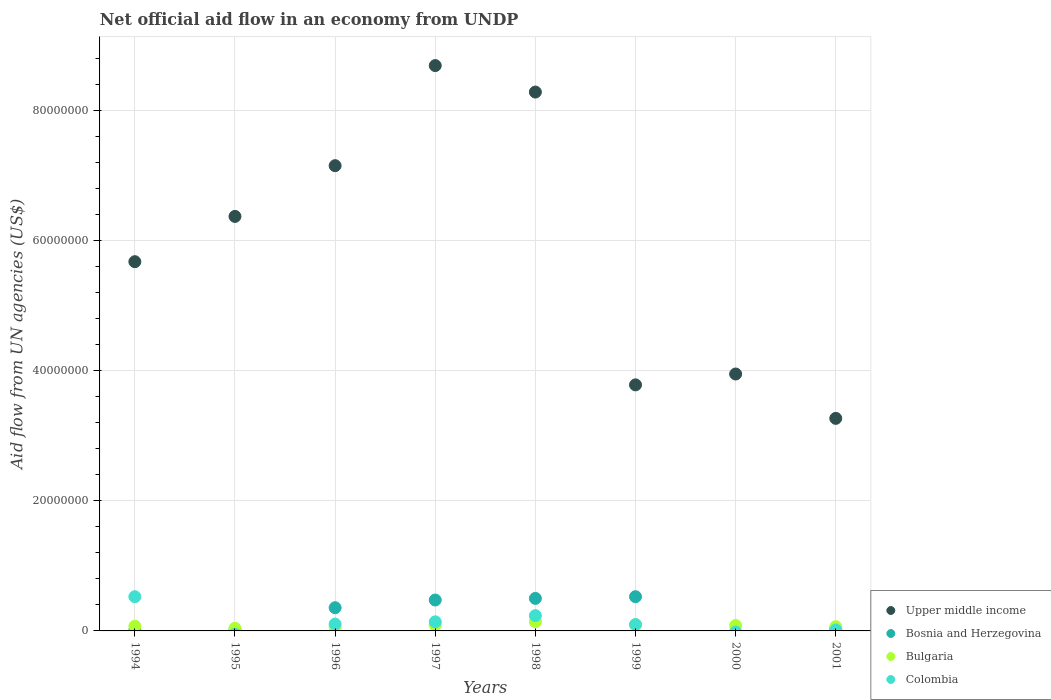How many different coloured dotlines are there?
Give a very brief answer. 4. Is the number of dotlines equal to the number of legend labels?
Your answer should be compact. No. What is the net official aid flow in Bosnia and Herzegovina in 1997?
Your answer should be compact. 4.75e+06. Across all years, what is the maximum net official aid flow in Colombia?
Provide a succinct answer. 5.26e+06. Across all years, what is the minimum net official aid flow in Bulgaria?
Your response must be concise. 4.00e+05. In which year was the net official aid flow in Upper middle income maximum?
Your answer should be very brief. 1997. What is the total net official aid flow in Upper middle income in the graph?
Offer a terse response. 4.72e+08. What is the difference between the net official aid flow in Colombia in 1997 and that in 2001?
Offer a terse response. 1.25e+06. What is the difference between the net official aid flow in Bosnia and Herzegovina in 1998 and the net official aid flow in Upper middle income in 1994?
Your answer should be very brief. -5.18e+07. What is the average net official aid flow in Bulgaria per year?
Ensure brevity in your answer.  8.10e+05. In the year 2001, what is the difference between the net official aid flow in Bosnia and Herzegovina and net official aid flow in Colombia?
Your response must be concise. 6.00e+04. What is the ratio of the net official aid flow in Bosnia and Herzegovina in 1997 to that in 1999?
Offer a terse response. 0.9. Is the net official aid flow in Upper middle income in 1994 less than that in 1997?
Provide a succinct answer. Yes. Is the difference between the net official aid flow in Bosnia and Herzegovina in 1994 and 1998 greater than the difference between the net official aid flow in Colombia in 1994 and 1998?
Your response must be concise. No. What is the difference between the highest and the second highest net official aid flow in Upper middle income?
Keep it short and to the point. 4.07e+06. What is the difference between the highest and the lowest net official aid flow in Upper middle income?
Your answer should be very brief. 5.42e+07. In how many years, is the net official aid flow in Bosnia and Herzegovina greater than the average net official aid flow in Bosnia and Herzegovina taken over all years?
Make the answer very short. 4. Is it the case that in every year, the sum of the net official aid flow in Upper middle income and net official aid flow in Bosnia and Herzegovina  is greater than the sum of net official aid flow in Colombia and net official aid flow in Bulgaria?
Give a very brief answer. Yes. Is it the case that in every year, the sum of the net official aid flow in Colombia and net official aid flow in Bosnia and Herzegovina  is greater than the net official aid flow in Bulgaria?
Your response must be concise. No. Is the net official aid flow in Colombia strictly greater than the net official aid flow in Upper middle income over the years?
Offer a terse response. No. How many years are there in the graph?
Provide a succinct answer. 8. What is the difference between two consecutive major ticks on the Y-axis?
Your answer should be compact. 2.00e+07. Are the values on the major ticks of Y-axis written in scientific E-notation?
Your response must be concise. No. Does the graph contain any zero values?
Give a very brief answer. Yes. Does the graph contain grids?
Your answer should be very brief. Yes. Where does the legend appear in the graph?
Your answer should be very brief. Bottom right. How many legend labels are there?
Your answer should be compact. 4. How are the legend labels stacked?
Your response must be concise. Vertical. What is the title of the graph?
Ensure brevity in your answer.  Net official aid flow in an economy from UNDP. What is the label or title of the X-axis?
Keep it short and to the point. Years. What is the label or title of the Y-axis?
Offer a very short reply. Aid flow from UN agencies (US$). What is the Aid flow from UN agencies (US$) in Upper middle income in 1994?
Offer a very short reply. 5.68e+07. What is the Aid flow from UN agencies (US$) of Bulgaria in 1994?
Your answer should be very brief. 7.20e+05. What is the Aid flow from UN agencies (US$) of Colombia in 1994?
Ensure brevity in your answer.  5.26e+06. What is the Aid flow from UN agencies (US$) of Upper middle income in 1995?
Your answer should be very brief. 6.37e+07. What is the Aid flow from UN agencies (US$) of Bosnia and Herzegovina in 1995?
Offer a terse response. 2.00e+05. What is the Aid flow from UN agencies (US$) in Upper middle income in 1996?
Your answer should be very brief. 7.15e+07. What is the Aid flow from UN agencies (US$) in Bosnia and Herzegovina in 1996?
Ensure brevity in your answer.  3.57e+06. What is the Aid flow from UN agencies (US$) in Colombia in 1996?
Your answer should be very brief. 1.05e+06. What is the Aid flow from UN agencies (US$) of Upper middle income in 1997?
Provide a short and direct response. 8.69e+07. What is the Aid flow from UN agencies (US$) of Bosnia and Herzegovina in 1997?
Offer a terse response. 4.75e+06. What is the Aid flow from UN agencies (US$) of Bulgaria in 1997?
Offer a terse response. 9.20e+05. What is the Aid flow from UN agencies (US$) in Colombia in 1997?
Make the answer very short. 1.40e+06. What is the Aid flow from UN agencies (US$) in Upper middle income in 1998?
Ensure brevity in your answer.  8.28e+07. What is the Aid flow from UN agencies (US$) of Bosnia and Herzegovina in 1998?
Provide a succinct answer. 5.00e+06. What is the Aid flow from UN agencies (US$) in Bulgaria in 1998?
Your answer should be very brief. 1.41e+06. What is the Aid flow from UN agencies (US$) of Colombia in 1998?
Provide a short and direct response. 2.35e+06. What is the Aid flow from UN agencies (US$) in Upper middle income in 1999?
Offer a terse response. 3.78e+07. What is the Aid flow from UN agencies (US$) of Bosnia and Herzegovina in 1999?
Give a very brief answer. 5.26e+06. What is the Aid flow from UN agencies (US$) of Bulgaria in 1999?
Offer a terse response. 9.50e+05. What is the Aid flow from UN agencies (US$) in Colombia in 1999?
Offer a terse response. 9.80e+05. What is the Aid flow from UN agencies (US$) in Upper middle income in 2000?
Offer a very short reply. 3.95e+07. What is the Aid flow from UN agencies (US$) of Bosnia and Herzegovina in 2000?
Your answer should be compact. 0. What is the Aid flow from UN agencies (US$) of Bulgaria in 2000?
Offer a terse response. 8.30e+05. What is the Aid flow from UN agencies (US$) in Upper middle income in 2001?
Provide a succinct answer. 3.27e+07. What is the Aid flow from UN agencies (US$) in Bulgaria in 2001?
Your response must be concise. 6.50e+05. Across all years, what is the maximum Aid flow from UN agencies (US$) in Upper middle income?
Offer a terse response. 8.69e+07. Across all years, what is the maximum Aid flow from UN agencies (US$) of Bosnia and Herzegovina?
Provide a succinct answer. 5.26e+06. Across all years, what is the maximum Aid flow from UN agencies (US$) in Bulgaria?
Your answer should be very brief. 1.41e+06. Across all years, what is the maximum Aid flow from UN agencies (US$) in Colombia?
Your response must be concise. 5.26e+06. Across all years, what is the minimum Aid flow from UN agencies (US$) of Upper middle income?
Make the answer very short. 3.27e+07. Across all years, what is the minimum Aid flow from UN agencies (US$) in Colombia?
Provide a succinct answer. 0. What is the total Aid flow from UN agencies (US$) of Upper middle income in the graph?
Make the answer very short. 4.72e+08. What is the total Aid flow from UN agencies (US$) in Bosnia and Herzegovina in the graph?
Give a very brief answer. 1.91e+07. What is the total Aid flow from UN agencies (US$) of Bulgaria in the graph?
Give a very brief answer. 6.48e+06. What is the total Aid flow from UN agencies (US$) in Colombia in the graph?
Your answer should be very brief. 1.12e+07. What is the difference between the Aid flow from UN agencies (US$) in Upper middle income in 1994 and that in 1995?
Your answer should be very brief. -6.96e+06. What is the difference between the Aid flow from UN agencies (US$) of Bulgaria in 1994 and that in 1995?
Your answer should be compact. 3.20e+05. What is the difference between the Aid flow from UN agencies (US$) of Upper middle income in 1994 and that in 1996?
Ensure brevity in your answer.  -1.48e+07. What is the difference between the Aid flow from UN agencies (US$) of Bosnia and Herzegovina in 1994 and that in 1996?
Ensure brevity in your answer.  -3.48e+06. What is the difference between the Aid flow from UN agencies (US$) of Colombia in 1994 and that in 1996?
Provide a succinct answer. 4.21e+06. What is the difference between the Aid flow from UN agencies (US$) of Upper middle income in 1994 and that in 1997?
Keep it short and to the point. -3.02e+07. What is the difference between the Aid flow from UN agencies (US$) of Bosnia and Herzegovina in 1994 and that in 1997?
Offer a very short reply. -4.66e+06. What is the difference between the Aid flow from UN agencies (US$) of Colombia in 1994 and that in 1997?
Your response must be concise. 3.86e+06. What is the difference between the Aid flow from UN agencies (US$) of Upper middle income in 1994 and that in 1998?
Provide a succinct answer. -2.61e+07. What is the difference between the Aid flow from UN agencies (US$) in Bosnia and Herzegovina in 1994 and that in 1998?
Ensure brevity in your answer.  -4.91e+06. What is the difference between the Aid flow from UN agencies (US$) in Bulgaria in 1994 and that in 1998?
Provide a succinct answer. -6.90e+05. What is the difference between the Aid flow from UN agencies (US$) of Colombia in 1994 and that in 1998?
Offer a very short reply. 2.91e+06. What is the difference between the Aid flow from UN agencies (US$) in Upper middle income in 1994 and that in 1999?
Your answer should be very brief. 1.89e+07. What is the difference between the Aid flow from UN agencies (US$) in Bosnia and Herzegovina in 1994 and that in 1999?
Provide a short and direct response. -5.17e+06. What is the difference between the Aid flow from UN agencies (US$) in Colombia in 1994 and that in 1999?
Provide a succinct answer. 4.28e+06. What is the difference between the Aid flow from UN agencies (US$) in Upper middle income in 1994 and that in 2000?
Give a very brief answer. 1.73e+07. What is the difference between the Aid flow from UN agencies (US$) in Bulgaria in 1994 and that in 2000?
Your answer should be compact. -1.10e+05. What is the difference between the Aid flow from UN agencies (US$) of Upper middle income in 1994 and that in 2001?
Give a very brief answer. 2.41e+07. What is the difference between the Aid flow from UN agencies (US$) of Bulgaria in 1994 and that in 2001?
Keep it short and to the point. 7.00e+04. What is the difference between the Aid flow from UN agencies (US$) in Colombia in 1994 and that in 2001?
Keep it short and to the point. 5.11e+06. What is the difference between the Aid flow from UN agencies (US$) in Upper middle income in 1995 and that in 1996?
Provide a short and direct response. -7.80e+06. What is the difference between the Aid flow from UN agencies (US$) of Bosnia and Herzegovina in 1995 and that in 1996?
Give a very brief answer. -3.37e+06. What is the difference between the Aid flow from UN agencies (US$) in Bulgaria in 1995 and that in 1996?
Provide a succinct answer. -2.00e+05. What is the difference between the Aid flow from UN agencies (US$) of Upper middle income in 1995 and that in 1997?
Offer a very short reply. -2.32e+07. What is the difference between the Aid flow from UN agencies (US$) in Bosnia and Herzegovina in 1995 and that in 1997?
Give a very brief answer. -4.55e+06. What is the difference between the Aid flow from UN agencies (US$) of Bulgaria in 1995 and that in 1997?
Provide a short and direct response. -5.20e+05. What is the difference between the Aid flow from UN agencies (US$) in Upper middle income in 1995 and that in 1998?
Offer a terse response. -1.91e+07. What is the difference between the Aid flow from UN agencies (US$) in Bosnia and Herzegovina in 1995 and that in 1998?
Provide a short and direct response. -4.80e+06. What is the difference between the Aid flow from UN agencies (US$) in Bulgaria in 1995 and that in 1998?
Your response must be concise. -1.01e+06. What is the difference between the Aid flow from UN agencies (US$) of Upper middle income in 1995 and that in 1999?
Provide a short and direct response. 2.59e+07. What is the difference between the Aid flow from UN agencies (US$) of Bosnia and Herzegovina in 1995 and that in 1999?
Provide a succinct answer. -5.06e+06. What is the difference between the Aid flow from UN agencies (US$) of Bulgaria in 1995 and that in 1999?
Offer a very short reply. -5.50e+05. What is the difference between the Aid flow from UN agencies (US$) in Upper middle income in 1995 and that in 2000?
Your answer should be compact. 2.42e+07. What is the difference between the Aid flow from UN agencies (US$) in Bulgaria in 1995 and that in 2000?
Offer a very short reply. -4.30e+05. What is the difference between the Aid flow from UN agencies (US$) in Upper middle income in 1995 and that in 2001?
Provide a succinct answer. 3.10e+07. What is the difference between the Aid flow from UN agencies (US$) in Bosnia and Herzegovina in 1995 and that in 2001?
Provide a short and direct response. -10000. What is the difference between the Aid flow from UN agencies (US$) in Bulgaria in 1995 and that in 2001?
Make the answer very short. -2.50e+05. What is the difference between the Aid flow from UN agencies (US$) of Upper middle income in 1996 and that in 1997?
Your response must be concise. -1.54e+07. What is the difference between the Aid flow from UN agencies (US$) in Bosnia and Herzegovina in 1996 and that in 1997?
Offer a terse response. -1.18e+06. What is the difference between the Aid flow from UN agencies (US$) in Bulgaria in 1996 and that in 1997?
Give a very brief answer. -3.20e+05. What is the difference between the Aid flow from UN agencies (US$) in Colombia in 1996 and that in 1997?
Ensure brevity in your answer.  -3.50e+05. What is the difference between the Aid flow from UN agencies (US$) in Upper middle income in 1996 and that in 1998?
Keep it short and to the point. -1.13e+07. What is the difference between the Aid flow from UN agencies (US$) in Bosnia and Herzegovina in 1996 and that in 1998?
Ensure brevity in your answer.  -1.43e+06. What is the difference between the Aid flow from UN agencies (US$) in Bulgaria in 1996 and that in 1998?
Provide a succinct answer. -8.10e+05. What is the difference between the Aid flow from UN agencies (US$) of Colombia in 1996 and that in 1998?
Your response must be concise. -1.30e+06. What is the difference between the Aid flow from UN agencies (US$) in Upper middle income in 1996 and that in 1999?
Keep it short and to the point. 3.37e+07. What is the difference between the Aid flow from UN agencies (US$) of Bosnia and Herzegovina in 1996 and that in 1999?
Your answer should be very brief. -1.69e+06. What is the difference between the Aid flow from UN agencies (US$) of Bulgaria in 1996 and that in 1999?
Your answer should be very brief. -3.50e+05. What is the difference between the Aid flow from UN agencies (US$) in Upper middle income in 1996 and that in 2000?
Provide a short and direct response. 3.20e+07. What is the difference between the Aid flow from UN agencies (US$) in Upper middle income in 1996 and that in 2001?
Keep it short and to the point. 3.88e+07. What is the difference between the Aid flow from UN agencies (US$) in Bosnia and Herzegovina in 1996 and that in 2001?
Offer a very short reply. 3.36e+06. What is the difference between the Aid flow from UN agencies (US$) in Colombia in 1996 and that in 2001?
Your response must be concise. 9.00e+05. What is the difference between the Aid flow from UN agencies (US$) of Upper middle income in 1997 and that in 1998?
Provide a succinct answer. 4.07e+06. What is the difference between the Aid flow from UN agencies (US$) in Bosnia and Herzegovina in 1997 and that in 1998?
Make the answer very short. -2.50e+05. What is the difference between the Aid flow from UN agencies (US$) in Bulgaria in 1997 and that in 1998?
Make the answer very short. -4.90e+05. What is the difference between the Aid flow from UN agencies (US$) of Colombia in 1997 and that in 1998?
Give a very brief answer. -9.50e+05. What is the difference between the Aid flow from UN agencies (US$) of Upper middle income in 1997 and that in 1999?
Your response must be concise. 4.91e+07. What is the difference between the Aid flow from UN agencies (US$) in Bosnia and Herzegovina in 1997 and that in 1999?
Ensure brevity in your answer.  -5.10e+05. What is the difference between the Aid flow from UN agencies (US$) in Bulgaria in 1997 and that in 1999?
Provide a succinct answer. -3.00e+04. What is the difference between the Aid flow from UN agencies (US$) in Colombia in 1997 and that in 1999?
Provide a short and direct response. 4.20e+05. What is the difference between the Aid flow from UN agencies (US$) of Upper middle income in 1997 and that in 2000?
Provide a succinct answer. 4.74e+07. What is the difference between the Aid flow from UN agencies (US$) of Upper middle income in 1997 and that in 2001?
Provide a short and direct response. 5.42e+07. What is the difference between the Aid flow from UN agencies (US$) in Bosnia and Herzegovina in 1997 and that in 2001?
Your answer should be compact. 4.54e+06. What is the difference between the Aid flow from UN agencies (US$) in Bulgaria in 1997 and that in 2001?
Provide a succinct answer. 2.70e+05. What is the difference between the Aid flow from UN agencies (US$) in Colombia in 1997 and that in 2001?
Offer a very short reply. 1.25e+06. What is the difference between the Aid flow from UN agencies (US$) in Upper middle income in 1998 and that in 1999?
Give a very brief answer. 4.50e+07. What is the difference between the Aid flow from UN agencies (US$) in Bulgaria in 1998 and that in 1999?
Give a very brief answer. 4.60e+05. What is the difference between the Aid flow from UN agencies (US$) of Colombia in 1998 and that in 1999?
Ensure brevity in your answer.  1.37e+06. What is the difference between the Aid flow from UN agencies (US$) in Upper middle income in 1998 and that in 2000?
Offer a terse response. 4.34e+07. What is the difference between the Aid flow from UN agencies (US$) of Bulgaria in 1998 and that in 2000?
Keep it short and to the point. 5.80e+05. What is the difference between the Aid flow from UN agencies (US$) in Upper middle income in 1998 and that in 2001?
Your answer should be very brief. 5.02e+07. What is the difference between the Aid flow from UN agencies (US$) in Bosnia and Herzegovina in 1998 and that in 2001?
Offer a very short reply. 4.79e+06. What is the difference between the Aid flow from UN agencies (US$) in Bulgaria in 1998 and that in 2001?
Provide a short and direct response. 7.60e+05. What is the difference between the Aid flow from UN agencies (US$) in Colombia in 1998 and that in 2001?
Provide a short and direct response. 2.20e+06. What is the difference between the Aid flow from UN agencies (US$) in Upper middle income in 1999 and that in 2000?
Provide a short and direct response. -1.67e+06. What is the difference between the Aid flow from UN agencies (US$) of Bulgaria in 1999 and that in 2000?
Give a very brief answer. 1.20e+05. What is the difference between the Aid flow from UN agencies (US$) of Upper middle income in 1999 and that in 2001?
Offer a very short reply. 5.15e+06. What is the difference between the Aid flow from UN agencies (US$) of Bosnia and Herzegovina in 1999 and that in 2001?
Ensure brevity in your answer.  5.05e+06. What is the difference between the Aid flow from UN agencies (US$) in Colombia in 1999 and that in 2001?
Your answer should be compact. 8.30e+05. What is the difference between the Aid flow from UN agencies (US$) of Upper middle income in 2000 and that in 2001?
Your response must be concise. 6.82e+06. What is the difference between the Aid flow from UN agencies (US$) of Bulgaria in 2000 and that in 2001?
Offer a terse response. 1.80e+05. What is the difference between the Aid flow from UN agencies (US$) in Upper middle income in 1994 and the Aid flow from UN agencies (US$) in Bosnia and Herzegovina in 1995?
Offer a very short reply. 5.66e+07. What is the difference between the Aid flow from UN agencies (US$) of Upper middle income in 1994 and the Aid flow from UN agencies (US$) of Bulgaria in 1995?
Offer a terse response. 5.64e+07. What is the difference between the Aid flow from UN agencies (US$) of Bosnia and Herzegovina in 1994 and the Aid flow from UN agencies (US$) of Bulgaria in 1995?
Provide a succinct answer. -3.10e+05. What is the difference between the Aid flow from UN agencies (US$) in Upper middle income in 1994 and the Aid flow from UN agencies (US$) in Bosnia and Herzegovina in 1996?
Give a very brief answer. 5.32e+07. What is the difference between the Aid flow from UN agencies (US$) of Upper middle income in 1994 and the Aid flow from UN agencies (US$) of Bulgaria in 1996?
Give a very brief answer. 5.62e+07. What is the difference between the Aid flow from UN agencies (US$) of Upper middle income in 1994 and the Aid flow from UN agencies (US$) of Colombia in 1996?
Give a very brief answer. 5.57e+07. What is the difference between the Aid flow from UN agencies (US$) of Bosnia and Herzegovina in 1994 and the Aid flow from UN agencies (US$) of Bulgaria in 1996?
Keep it short and to the point. -5.10e+05. What is the difference between the Aid flow from UN agencies (US$) of Bosnia and Herzegovina in 1994 and the Aid flow from UN agencies (US$) of Colombia in 1996?
Provide a succinct answer. -9.60e+05. What is the difference between the Aid flow from UN agencies (US$) in Bulgaria in 1994 and the Aid flow from UN agencies (US$) in Colombia in 1996?
Ensure brevity in your answer.  -3.30e+05. What is the difference between the Aid flow from UN agencies (US$) of Upper middle income in 1994 and the Aid flow from UN agencies (US$) of Bosnia and Herzegovina in 1997?
Make the answer very short. 5.20e+07. What is the difference between the Aid flow from UN agencies (US$) in Upper middle income in 1994 and the Aid flow from UN agencies (US$) in Bulgaria in 1997?
Your answer should be very brief. 5.58e+07. What is the difference between the Aid flow from UN agencies (US$) of Upper middle income in 1994 and the Aid flow from UN agencies (US$) of Colombia in 1997?
Your answer should be very brief. 5.54e+07. What is the difference between the Aid flow from UN agencies (US$) in Bosnia and Herzegovina in 1994 and the Aid flow from UN agencies (US$) in Bulgaria in 1997?
Keep it short and to the point. -8.30e+05. What is the difference between the Aid flow from UN agencies (US$) in Bosnia and Herzegovina in 1994 and the Aid flow from UN agencies (US$) in Colombia in 1997?
Keep it short and to the point. -1.31e+06. What is the difference between the Aid flow from UN agencies (US$) of Bulgaria in 1994 and the Aid flow from UN agencies (US$) of Colombia in 1997?
Your answer should be compact. -6.80e+05. What is the difference between the Aid flow from UN agencies (US$) of Upper middle income in 1994 and the Aid flow from UN agencies (US$) of Bosnia and Herzegovina in 1998?
Offer a terse response. 5.18e+07. What is the difference between the Aid flow from UN agencies (US$) of Upper middle income in 1994 and the Aid flow from UN agencies (US$) of Bulgaria in 1998?
Provide a succinct answer. 5.54e+07. What is the difference between the Aid flow from UN agencies (US$) in Upper middle income in 1994 and the Aid flow from UN agencies (US$) in Colombia in 1998?
Your answer should be very brief. 5.44e+07. What is the difference between the Aid flow from UN agencies (US$) in Bosnia and Herzegovina in 1994 and the Aid flow from UN agencies (US$) in Bulgaria in 1998?
Provide a succinct answer. -1.32e+06. What is the difference between the Aid flow from UN agencies (US$) of Bosnia and Herzegovina in 1994 and the Aid flow from UN agencies (US$) of Colombia in 1998?
Keep it short and to the point. -2.26e+06. What is the difference between the Aid flow from UN agencies (US$) in Bulgaria in 1994 and the Aid flow from UN agencies (US$) in Colombia in 1998?
Make the answer very short. -1.63e+06. What is the difference between the Aid flow from UN agencies (US$) in Upper middle income in 1994 and the Aid flow from UN agencies (US$) in Bosnia and Herzegovina in 1999?
Keep it short and to the point. 5.15e+07. What is the difference between the Aid flow from UN agencies (US$) of Upper middle income in 1994 and the Aid flow from UN agencies (US$) of Bulgaria in 1999?
Provide a short and direct response. 5.58e+07. What is the difference between the Aid flow from UN agencies (US$) in Upper middle income in 1994 and the Aid flow from UN agencies (US$) in Colombia in 1999?
Your response must be concise. 5.58e+07. What is the difference between the Aid flow from UN agencies (US$) of Bosnia and Herzegovina in 1994 and the Aid flow from UN agencies (US$) of Bulgaria in 1999?
Offer a terse response. -8.60e+05. What is the difference between the Aid flow from UN agencies (US$) of Bosnia and Herzegovina in 1994 and the Aid flow from UN agencies (US$) of Colombia in 1999?
Your answer should be very brief. -8.90e+05. What is the difference between the Aid flow from UN agencies (US$) of Upper middle income in 1994 and the Aid flow from UN agencies (US$) of Bulgaria in 2000?
Provide a short and direct response. 5.59e+07. What is the difference between the Aid flow from UN agencies (US$) in Bosnia and Herzegovina in 1994 and the Aid flow from UN agencies (US$) in Bulgaria in 2000?
Make the answer very short. -7.40e+05. What is the difference between the Aid flow from UN agencies (US$) in Upper middle income in 1994 and the Aid flow from UN agencies (US$) in Bosnia and Herzegovina in 2001?
Ensure brevity in your answer.  5.66e+07. What is the difference between the Aid flow from UN agencies (US$) of Upper middle income in 1994 and the Aid flow from UN agencies (US$) of Bulgaria in 2001?
Offer a terse response. 5.61e+07. What is the difference between the Aid flow from UN agencies (US$) in Upper middle income in 1994 and the Aid flow from UN agencies (US$) in Colombia in 2001?
Make the answer very short. 5.66e+07. What is the difference between the Aid flow from UN agencies (US$) of Bosnia and Herzegovina in 1994 and the Aid flow from UN agencies (US$) of Bulgaria in 2001?
Your answer should be compact. -5.60e+05. What is the difference between the Aid flow from UN agencies (US$) in Bosnia and Herzegovina in 1994 and the Aid flow from UN agencies (US$) in Colombia in 2001?
Provide a succinct answer. -6.00e+04. What is the difference between the Aid flow from UN agencies (US$) of Bulgaria in 1994 and the Aid flow from UN agencies (US$) of Colombia in 2001?
Keep it short and to the point. 5.70e+05. What is the difference between the Aid flow from UN agencies (US$) of Upper middle income in 1995 and the Aid flow from UN agencies (US$) of Bosnia and Herzegovina in 1996?
Your answer should be very brief. 6.02e+07. What is the difference between the Aid flow from UN agencies (US$) of Upper middle income in 1995 and the Aid flow from UN agencies (US$) of Bulgaria in 1996?
Keep it short and to the point. 6.31e+07. What is the difference between the Aid flow from UN agencies (US$) of Upper middle income in 1995 and the Aid flow from UN agencies (US$) of Colombia in 1996?
Offer a very short reply. 6.27e+07. What is the difference between the Aid flow from UN agencies (US$) of Bosnia and Herzegovina in 1995 and the Aid flow from UN agencies (US$) of Bulgaria in 1996?
Provide a succinct answer. -4.00e+05. What is the difference between the Aid flow from UN agencies (US$) of Bosnia and Herzegovina in 1995 and the Aid flow from UN agencies (US$) of Colombia in 1996?
Your response must be concise. -8.50e+05. What is the difference between the Aid flow from UN agencies (US$) in Bulgaria in 1995 and the Aid flow from UN agencies (US$) in Colombia in 1996?
Ensure brevity in your answer.  -6.50e+05. What is the difference between the Aid flow from UN agencies (US$) in Upper middle income in 1995 and the Aid flow from UN agencies (US$) in Bosnia and Herzegovina in 1997?
Your answer should be compact. 5.90e+07. What is the difference between the Aid flow from UN agencies (US$) of Upper middle income in 1995 and the Aid flow from UN agencies (US$) of Bulgaria in 1997?
Your answer should be compact. 6.28e+07. What is the difference between the Aid flow from UN agencies (US$) of Upper middle income in 1995 and the Aid flow from UN agencies (US$) of Colombia in 1997?
Offer a terse response. 6.23e+07. What is the difference between the Aid flow from UN agencies (US$) of Bosnia and Herzegovina in 1995 and the Aid flow from UN agencies (US$) of Bulgaria in 1997?
Your answer should be very brief. -7.20e+05. What is the difference between the Aid flow from UN agencies (US$) of Bosnia and Herzegovina in 1995 and the Aid flow from UN agencies (US$) of Colombia in 1997?
Your response must be concise. -1.20e+06. What is the difference between the Aid flow from UN agencies (US$) in Upper middle income in 1995 and the Aid flow from UN agencies (US$) in Bosnia and Herzegovina in 1998?
Your response must be concise. 5.87e+07. What is the difference between the Aid flow from UN agencies (US$) in Upper middle income in 1995 and the Aid flow from UN agencies (US$) in Bulgaria in 1998?
Offer a terse response. 6.23e+07. What is the difference between the Aid flow from UN agencies (US$) of Upper middle income in 1995 and the Aid flow from UN agencies (US$) of Colombia in 1998?
Your answer should be very brief. 6.14e+07. What is the difference between the Aid flow from UN agencies (US$) of Bosnia and Herzegovina in 1995 and the Aid flow from UN agencies (US$) of Bulgaria in 1998?
Ensure brevity in your answer.  -1.21e+06. What is the difference between the Aid flow from UN agencies (US$) of Bosnia and Herzegovina in 1995 and the Aid flow from UN agencies (US$) of Colombia in 1998?
Make the answer very short. -2.15e+06. What is the difference between the Aid flow from UN agencies (US$) in Bulgaria in 1995 and the Aid flow from UN agencies (US$) in Colombia in 1998?
Give a very brief answer. -1.95e+06. What is the difference between the Aid flow from UN agencies (US$) in Upper middle income in 1995 and the Aid flow from UN agencies (US$) in Bosnia and Herzegovina in 1999?
Your response must be concise. 5.85e+07. What is the difference between the Aid flow from UN agencies (US$) in Upper middle income in 1995 and the Aid flow from UN agencies (US$) in Bulgaria in 1999?
Your response must be concise. 6.28e+07. What is the difference between the Aid flow from UN agencies (US$) of Upper middle income in 1995 and the Aid flow from UN agencies (US$) of Colombia in 1999?
Offer a terse response. 6.28e+07. What is the difference between the Aid flow from UN agencies (US$) in Bosnia and Herzegovina in 1995 and the Aid flow from UN agencies (US$) in Bulgaria in 1999?
Your response must be concise. -7.50e+05. What is the difference between the Aid flow from UN agencies (US$) of Bosnia and Herzegovina in 1995 and the Aid flow from UN agencies (US$) of Colombia in 1999?
Offer a very short reply. -7.80e+05. What is the difference between the Aid flow from UN agencies (US$) in Bulgaria in 1995 and the Aid flow from UN agencies (US$) in Colombia in 1999?
Provide a short and direct response. -5.80e+05. What is the difference between the Aid flow from UN agencies (US$) of Upper middle income in 1995 and the Aid flow from UN agencies (US$) of Bulgaria in 2000?
Provide a succinct answer. 6.29e+07. What is the difference between the Aid flow from UN agencies (US$) in Bosnia and Herzegovina in 1995 and the Aid flow from UN agencies (US$) in Bulgaria in 2000?
Your answer should be very brief. -6.30e+05. What is the difference between the Aid flow from UN agencies (US$) of Upper middle income in 1995 and the Aid flow from UN agencies (US$) of Bosnia and Herzegovina in 2001?
Make the answer very short. 6.35e+07. What is the difference between the Aid flow from UN agencies (US$) in Upper middle income in 1995 and the Aid flow from UN agencies (US$) in Bulgaria in 2001?
Give a very brief answer. 6.31e+07. What is the difference between the Aid flow from UN agencies (US$) of Upper middle income in 1995 and the Aid flow from UN agencies (US$) of Colombia in 2001?
Keep it short and to the point. 6.36e+07. What is the difference between the Aid flow from UN agencies (US$) of Bosnia and Herzegovina in 1995 and the Aid flow from UN agencies (US$) of Bulgaria in 2001?
Keep it short and to the point. -4.50e+05. What is the difference between the Aid flow from UN agencies (US$) of Bosnia and Herzegovina in 1995 and the Aid flow from UN agencies (US$) of Colombia in 2001?
Your answer should be compact. 5.00e+04. What is the difference between the Aid flow from UN agencies (US$) of Bulgaria in 1995 and the Aid flow from UN agencies (US$) of Colombia in 2001?
Offer a terse response. 2.50e+05. What is the difference between the Aid flow from UN agencies (US$) in Upper middle income in 1996 and the Aid flow from UN agencies (US$) in Bosnia and Herzegovina in 1997?
Make the answer very short. 6.68e+07. What is the difference between the Aid flow from UN agencies (US$) in Upper middle income in 1996 and the Aid flow from UN agencies (US$) in Bulgaria in 1997?
Provide a succinct answer. 7.06e+07. What is the difference between the Aid flow from UN agencies (US$) of Upper middle income in 1996 and the Aid flow from UN agencies (US$) of Colombia in 1997?
Ensure brevity in your answer.  7.01e+07. What is the difference between the Aid flow from UN agencies (US$) in Bosnia and Herzegovina in 1996 and the Aid flow from UN agencies (US$) in Bulgaria in 1997?
Ensure brevity in your answer.  2.65e+06. What is the difference between the Aid flow from UN agencies (US$) of Bosnia and Herzegovina in 1996 and the Aid flow from UN agencies (US$) of Colombia in 1997?
Ensure brevity in your answer.  2.17e+06. What is the difference between the Aid flow from UN agencies (US$) of Bulgaria in 1996 and the Aid flow from UN agencies (US$) of Colombia in 1997?
Offer a terse response. -8.00e+05. What is the difference between the Aid flow from UN agencies (US$) of Upper middle income in 1996 and the Aid flow from UN agencies (US$) of Bosnia and Herzegovina in 1998?
Provide a short and direct response. 6.65e+07. What is the difference between the Aid flow from UN agencies (US$) of Upper middle income in 1996 and the Aid flow from UN agencies (US$) of Bulgaria in 1998?
Your answer should be compact. 7.01e+07. What is the difference between the Aid flow from UN agencies (US$) of Upper middle income in 1996 and the Aid flow from UN agencies (US$) of Colombia in 1998?
Ensure brevity in your answer.  6.92e+07. What is the difference between the Aid flow from UN agencies (US$) of Bosnia and Herzegovina in 1996 and the Aid flow from UN agencies (US$) of Bulgaria in 1998?
Give a very brief answer. 2.16e+06. What is the difference between the Aid flow from UN agencies (US$) of Bosnia and Herzegovina in 1996 and the Aid flow from UN agencies (US$) of Colombia in 1998?
Give a very brief answer. 1.22e+06. What is the difference between the Aid flow from UN agencies (US$) of Bulgaria in 1996 and the Aid flow from UN agencies (US$) of Colombia in 1998?
Make the answer very short. -1.75e+06. What is the difference between the Aid flow from UN agencies (US$) of Upper middle income in 1996 and the Aid flow from UN agencies (US$) of Bosnia and Herzegovina in 1999?
Provide a short and direct response. 6.63e+07. What is the difference between the Aid flow from UN agencies (US$) in Upper middle income in 1996 and the Aid flow from UN agencies (US$) in Bulgaria in 1999?
Ensure brevity in your answer.  7.06e+07. What is the difference between the Aid flow from UN agencies (US$) of Upper middle income in 1996 and the Aid flow from UN agencies (US$) of Colombia in 1999?
Your answer should be compact. 7.06e+07. What is the difference between the Aid flow from UN agencies (US$) in Bosnia and Herzegovina in 1996 and the Aid flow from UN agencies (US$) in Bulgaria in 1999?
Your response must be concise. 2.62e+06. What is the difference between the Aid flow from UN agencies (US$) in Bosnia and Herzegovina in 1996 and the Aid flow from UN agencies (US$) in Colombia in 1999?
Make the answer very short. 2.59e+06. What is the difference between the Aid flow from UN agencies (US$) in Bulgaria in 1996 and the Aid flow from UN agencies (US$) in Colombia in 1999?
Your answer should be compact. -3.80e+05. What is the difference between the Aid flow from UN agencies (US$) in Upper middle income in 1996 and the Aid flow from UN agencies (US$) in Bulgaria in 2000?
Your answer should be very brief. 7.07e+07. What is the difference between the Aid flow from UN agencies (US$) in Bosnia and Herzegovina in 1996 and the Aid flow from UN agencies (US$) in Bulgaria in 2000?
Your response must be concise. 2.74e+06. What is the difference between the Aid flow from UN agencies (US$) of Upper middle income in 1996 and the Aid flow from UN agencies (US$) of Bosnia and Herzegovina in 2001?
Ensure brevity in your answer.  7.13e+07. What is the difference between the Aid flow from UN agencies (US$) of Upper middle income in 1996 and the Aid flow from UN agencies (US$) of Bulgaria in 2001?
Offer a terse response. 7.09e+07. What is the difference between the Aid flow from UN agencies (US$) of Upper middle income in 1996 and the Aid flow from UN agencies (US$) of Colombia in 2001?
Provide a succinct answer. 7.14e+07. What is the difference between the Aid flow from UN agencies (US$) in Bosnia and Herzegovina in 1996 and the Aid flow from UN agencies (US$) in Bulgaria in 2001?
Offer a very short reply. 2.92e+06. What is the difference between the Aid flow from UN agencies (US$) of Bosnia and Herzegovina in 1996 and the Aid flow from UN agencies (US$) of Colombia in 2001?
Your answer should be compact. 3.42e+06. What is the difference between the Aid flow from UN agencies (US$) in Upper middle income in 1997 and the Aid flow from UN agencies (US$) in Bosnia and Herzegovina in 1998?
Give a very brief answer. 8.19e+07. What is the difference between the Aid flow from UN agencies (US$) in Upper middle income in 1997 and the Aid flow from UN agencies (US$) in Bulgaria in 1998?
Ensure brevity in your answer.  8.55e+07. What is the difference between the Aid flow from UN agencies (US$) of Upper middle income in 1997 and the Aid flow from UN agencies (US$) of Colombia in 1998?
Keep it short and to the point. 8.46e+07. What is the difference between the Aid flow from UN agencies (US$) of Bosnia and Herzegovina in 1997 and the Aid flow from UN agencies (US$) of Bulgaria in 1998?
Your answer should be compact. 3.34e+06. What is the difference between the Aid flow from UN agencies (US$) of Bosnia and Herzegovina in 1997 and the Aid flow from UN agencies (US$) of Colombia in 1998?
Your answer should be very brief. 2.40e+06. What is the difference between the Aid flow from UN agencies (US$) of Bulgaria in 1997 and the Aid flow from UN agencies (US$) of Colombia in 1998?
Give a very brief answer. -1.43e+06. What is the difference between the Aid flow from UN agencies (US$) of Upper middle income in 1997 and the Aid flow from UN agencies (US$) of Bosnia and Herzegovina in 1999?
Provide a short and direct response. 8.17e+07. What is the difference between the Aid flow from UN agencies (US$) in Upper middle income in 1997 and the Aid flow from UN agencies (US$) in Bulgaria in 1999?
Your answer should be very brief. 8.60e+07. What is the difference between the Aid flow from UN agencies (US$) in Upper middle income in 1997 and the Aid flow from UN agencies (US$) in Colombia in 1999?
Offer a terse response. 8.59e+07. What is the difference between the Aid flow from UN agencies (US$) of Bosnia and Herzegovina in 1997 and the Aid flow from UN agencies (US$) of Bulgaria in 1999?
Provide a succinct answer. 3.80e+06. What is the difference between the Aid flow from UN agencies (US$) of Bosnia and Herzegovina in 1997 and the Aid flow from UN agencies (US$) of Colombia in 1999?
Provide a succinct answer. 3.77e+06. What is the difference between the Aid flow from UN agencies (US$) of Upper middle income in 1997 and the Aid flow from UN agencies (US$) of Bulgaria in 2000?
Offer a very short reply. 8.61e+07. What is the difference between the Aid flow from UN agencies (US$) in Bosnia and Herzegovina in 1997 and the Aid flow from UN agencies (US$) in Bulgaria in 2000?
Offer a very short reply. 3.92e+06. What is the difference between the Aid flow from UN agencies (US$) in Upper middle income in 1997 and the Aid flow from UN agencies (US$) in Bosnia and Herzegovina in 2001?
Give a very brief answer. 8.67e+07. What is the difference between the Aid flow from UN agencies (US$) in Upper middle income in 1997 and the Aid flow from UN agencies (US$) in Bulgaria in 2001?
Ensure brevity in your answer.  8.63e+07. What is the difference between the Aid flow from UN agencies (US$) in Upper middle income in 1997 and the Aid flow from UN agencies (US$) in Colombia in 2001?
Give a very brief answer. 8.68e+07. What is the difference between the Aid flow from UN agencies (US$) of Bosnia and Herzegovina in 1997 and the Aid flow from UN agencies (US$) of Bulgaria in 2001?
Offer a terse response. 4.10e+06. What is the difference between the Aid flow from UN agencies (US$) in Bosnia and Herzegovina in 1997 and the Aid flow from UN agencies (US$) in Colombia in 2001?
Make the answer very short. 4.60e+06. What is the difference between the Aid flow from UN agencies (US$) of Bulgaria in 1997 and the Aid flow from UN agencies (US$) of Colombia in 2001?
Your answer should be very brief. 7.70e+05. What is the difference between the Aid flow from UN agencies (US$) of Upper middle income in 1998 and the Aid flow from UN agencies (US$) of Bosnia and Herzegovina in 1999?
Your response must be concise. 7.76e+07. What is the difference between the Aid flow from UN agencies (US$) in Upper middle income in 1998 and the Aid flow from UN agencies (US$) in Bulgaria in 1999?
Ensure brevity in your answer.  8.19e+07. What is the difference between the Aid flow from UN agencies (US$) in Upper middle income in 1998 and the Aid flow from UN agencies (US$) in Colombia in 1999?
Provide a short and direct response. 8.19e+07. What is the difference between the Aid flow from UN agencies (US$) in Bosnia and Herzegovina in 1998 and the Aid flow from UN agencies (US$) in Bulgaria in 1999?
Give a very brief answer. 4.05e+06. What is the difference between the Aid flow from UN agencies (US$) of Bosnia and Herzegovina in 1998 and the Aid flow from UN agencies (US$) of Colombia in 1999?
Keep it short and to the point. 4.02e+06. What is the difference between the Aid flow from UN agencies (US$) of Upper middle income in 1998 and the Aid flow from UN agencies (US$) of Bulgaria in 2000?
Offer a terse response. 8.20e+07. What is the difference between the Aid flow from UN agencies (US$) of Bosnia and Herzegovina in 1998 and the Aid flow from UN agencies (US$) of Bulgaria in 2000?
Keep it short and to the point. 4.17e+06. What is the difference between the Aid flow from UN agencies (US$) in Upper middle income in 1998 and the Aid flow from UN agencies (US$) in Bosnia and Herzegovina in 2001?
Offer a very short reply. 8.26e+07. What is the difference between the Aid flow from UN agencies (US$) of Upper middle income in 1998 and the Aid flow from UN agencies (US$) of Bulgaria in 2001?
Provide a short and direct response. 8.22e+07. What is the difference between the Aid flow from UN agencies (US$) in Upper middle income in 1998 and the Aid flow from UN agencies (US$) in Colombia in 2001?
Provide a succinct answer. 8.27e+07. What is the difference between the Aid flow from UN agencies (US$) in Bosnia and Herzegovina in 1998 and the Aid flow from UN agencies (US$) in Bulgaria in 2001?
Your response must be concise. 4.35e+06. What is the difference between the Aid flow from UN agencies (US$) of Bosnia and Herzegovina in 1998 and the Aid flow from UN agencies (US$) of Colombia in 2001?
Ensure brevity in your answer.  4.85e+06. What is the difference between the Aid flow from UN agencies (US$) of Bulgaria in 1998 and the Aid flow from UN agencies (US$) of Colombia in 2001?
Your answer should be very brief. 1.26e+06. What is the difference between the Aid flow from UN agencies (US$) of Upper middle income in 1999 and the Aid flow from UN agencies (US$) of Bulgaria in 2000?
Keep it short and to the point. 3.70e+07. What is the difference between the Aid flow from UN agencies (US$) in Bosnia and Herzegovina in 1999 and the Aid flow from UN agencies (US$) in Bulgaria in 2000?
Ensure brevity in your answer.  4.43e+06. What is the difference between the Aid flow from UN agencies (US$) of Upper middle income in 1999 and the Aid flow from UN agencies (US$) of Bosnia and Herzegovina in 2001?
Give a very brief answer. 3.76e+07. What is the difference between the Aid flow from UN agencies (US$) in Upper middle income in 1999 and the Aid flow from UN agencies (US$) in Bulgaria in 2001?
Offer a very short reply. 3.72e+07. What is the difference between the Aid flow from UN agencies (US$) of Upper middle income in 1999 and the Aid flow from UN agencies (US$) of Colombia in 2001?
Offer a terse response. 3.77e+07. What is the difference between the Aid flow from UN agencies (US$) in Bosnia and Herzegovina in 1999 and the Aid flow from UN agencies (US$) in Bulgaria in 2001?
Make the answer very short. 4.61e+06. What is the difference between the Aid flow from UN agencies (US$) of Bosnia and Herzegovina in 1999 and the Aid flow from UN agencies (US$) of Colombia in 2001?
Keep it short and to the point. 5.11e+06. What is the difference between the Aid flow from UN agencies (US$) of Upper middle income in 2000 and the Aid flow from UN agencies (US$) of Bosnia and Herzegovina in 2001?
Your answer should be compact. 3.93e+07. What is the difference between the Aid flow from UN agencies (US$) in Upper middle income in 2000 and the Aid flow from UN agencies (US$) in Bulgaria in 2001?
Your answer should be compact. 3.88e+07. What is the difference between the Aid flow from UN agencies (US$) of Upper middle income in 2000 and the Aid flow from UN agencies (US$) of Colombia in 2001?
Your answer should be compact. 3.94e+07. What is the difference between the Aid flow from UN agencies (US$) of Bulgaria in 2000 and the Aid flow from UN agencies (US$) of Colombia in 2001?
Provide a short and direct response. 6.80e+05. What is the average Aid flow from UN agencies (US$) of Upper middle income per year?
Provide a short and direct response. 5.90e+07. What is the average Aid flow from UN agencies (US$) in Bosnia and Herzegovina per year?
Your response must be concise. 2.38e+06. What is the average Aid flow from UN agencies (US$) of Bulgaria per year?
Offer a terse response. 8.10e+05. What is the average Aid flow from UN agencies (US$) in Colombia per year?
Provide a short and direct response. 1.40e+06. In the year 1994, what is the difference between the Aid flow from UN agencies (US$) in Upper middle income and Aid flow from UN agencies (US$) in Bosnia and Herzegovina?
Offer a terse response. 5.67e+07. In the year 1994, what is the difference between the Aid flow from UN agencies (US$) of Upper middle income and Aid flow from UN agencies (US$) of Bulgaria?
Make the answer very short. 5.60e+07. In the year 1994, what is the difference between the Aid flow from UN agencies (US$) of Upper middle income and Aid flow from UN agencies (US$) of Colombia?
Offer a very short reply. 5.15e+07. In the year 1994, what is the difference between the Aid flow from UN agencies (US$) in Bosnia and Herzegovina and Aid flow from UN agencies (US$) in Bulgaria?
Offer a terse response. -6.30e+05. In the year 1994, what is the difference between the Aid flow from UN agencies (US$) in Bosnia and Herzegovina and Aid flow from UN agencies (US$) in Colombia?
Offer a very short reply. -5.17e+06. In the year 1994, what is the difference between the Aid flow from UN agencies (US$) in Bulgaria and Aid flow from UN agencies (US$) in Colombia?
Give a very brief answer. -4.54e+06. In the year 1995, what is the difference between the Aid flow from UN agencies (US$) of Upper middle income and Aid flow from UN agencies (US$) of Bosnia and Herzegovina?
Ensure brevity in your answer.  6.35e+07. In the year 1995, what is the difference between the Aid flow from UN agencies (US$) in Upper middle income and Aid flow from UN agencies (US$) in Bulgaria?
Your answer should be very brief. 6.33e+07. In the year 1996, what is the difference between the Aid flow from UN agencies (US$) of Upper middle income and Aid flow from UN agencies (US$) of Bosnia and Herzegovina?
Provide a succinct answer. 6.80e+07. In the year 1996, what is the difference between the Aid flow from UN agencies (US$) in Upper middle income and Aid flow from UN agencies (US$) in Bulgaria?
Provide a succinct answer. 7.09e+07. In the year 1996, what is the difference between the Aid flow from UN agencies (US$) in Upper middle income and Aid flow from UN agencies (US$) in Colombia?
Your answer should be very brief. 7.05e+07. In the year 1996, what is the difference between the Aid flow from UN agencies (US$) of Bosnia and Herzegovina and Aid flow from UN agencies (US$) of Bulgaria?
Make the answer very short. 2.97e+06. In the year 1996, what is the difference between the Aid flow from UN agencies (US$) of Bosnia and Herzegovina and Aid flow from UN agencies (US$) of Colombia?
Keep it short and to the point. 2.52e+06. In the year 1996, what is the difference between the Aid flow from UN agencies (US$) in Bulgaria and Aid flow from UN agencies (US$) in Colombia?
Your response must be concise. -4.50e+05. In the year 1997, what is the difference between the Aid flow from UN agencies (US$) of Upper middle income and Aid flow from UN agencies (US$) of Bosnia and Herzegovina?
Provide a short and direct response. 8.22e+07. In the year 1997, what is the difference between the Aid flow from UN agencies (US$) of Upper middle income and Aid flow from UN agencies (US$) of Bulgaria?
Provide a succinct answer. 8.60e+07. In the year 1997, what is the difference between the Aid flow from UN agencies (US$) of Upper middle income and Aid flow from UN agencies (US$) of Colombia?
Provide a short and direct response. 8.55e+07. In the year 1997, what is the difference between the Aid flow from UN agencies (US$) in Bosnia and Herzegovina and Aid flow from UN agencies (US$) in Bulgaria?
Your answer should be compact. 3.83e+06. In the year 1997, what is the difference between the Aid flow from UN agencies (US$) of Bosnia and Herzegovina and Aid flow from UN agencies (US$) of Colombia?
Make the answer very short. 3.35e+06. In the year 1997, what is the difference between the Aid flow from UN agencies (US$) in Bulgaria and Aid flow from UN agencies (US$) in Colombia?
Keep it short and to the point. -4.80e+05. In the year 1998, what is the difference between the Aid flow from UN agencies (US$) in Upper middle income and Aid flow from UN agencies (US$) in Bosnia and Herzegovina?
Offer a terse response. 7.78e+07. In the year 1998, what is the difference between the Aid flow from UN agencies (US$) of Upper middle income and Aid flow from UN agencies (US$) of Bulgaria?
Give a very brief answer. 8.14e+07. In the year 1998, what is the difference between the Aid flow from UN agencies (US$) of Upper middle income and Aid flow from UN agencies (US$) of Colombia?
Offer a terse response. 8.05e+07. In the year 1998, what is the difference between the Aid flow from UN agencies (US$) in Bosnia and Herzegovina and Aid flow from UN agencies (US$) in Bulgaria?
Offer a terse response. 3.59e+06. In the year 1998, what is the difference between the Aid flow from UN agencies (US$) of Bosnia and Herzegovina and Aid flow from UN agencies (US$) of Colombia?
Your response must be concise. 2.65e+06. In the year 1998, what is the difference between the Aid flow from UN agencies (US$) of Bulgaria and Aid flow from UN agencies (US$) of Colombia?
Your answer should be compact. -9.40e+05. In the year 1999, what is the difference between the Aid flow from UN agencies (US$) in Upper middle income and Aid flow from UN agencies (US$) in Bosnia and Herzegovina?
Ensure brevity in your answer.  3.26e+07. In the year 1999, what is the difference between the Aid flow from UN agencies (US$) in Upper middle income and Aid flow from UN agencies (US$) in Bulgaria?
Offer a terse response. 3.69e+07. In the year 1999, what is the difference between the Aid flow from UN agencies (US$) of Upper middle income and Aid flow from UN agencies (US$) of Colombia?
Provide a short and direct response. 3.68e+07. In the year 1999, what is the difference between the Aid flow from UN agencies (US$) in Bosnia and Herzegovina and Aid flow from UN agencies (US$) in Bulgaria?
Provide a short and direct response. 4.31e+06. In the year 1999, what is the difference between the Aid flow from UN agencies (US$) of Bosnia and Herzegovina and Aid flow from UN agencies (US$) of Colombia?
Keep it short and to the point. 4.28e+06. In the year 1999, what is the difference between the Aid flow from UN agencies (US$) of Bulgaria and Aid flow from UN agencies (US$) of Colombia?
Your response must be concise. -3.00e+04. In the year 2000, what is the difference between the Aid flow from UN agencies (US$) of Upper middle income and Aid flow from UN agencies (US$) of Bulgaria?
Your answer should be compact. 3.87e+07. In the year 2001, what is the difference between the Aid flow from UN agencies (US$) in Upper middle income and Aid flow from UN agencies (US$) in Bosnia and Herzegovina?
Keep it short and to the point. 3.25e+07. In the year 2001, what is the difference between the Aid flow from UN agencies (US$) in Upper middle income and Aid flow from UN agencies (US$) in Bulgaria?
Offer a very short reply. 3.20e+07. In the year 2001, what is the difference between the Aid flow from UN agencies (US$) of Upper middle income and Aid flow from UN agencies (US$) of Colombia?
Your answer should be very brief. 3.25e+07. In the year 2001, what is the difference between the Aid flow from UN agencies (US$) in Bosnia and Herzegovina and Aid flow from UN agencies (US$) in Bulgaria?
Your answer should be very brief. -4.40e+05. In the year 2001, what is the difference between the Aid flow from UN agencies (US$) of Bosnia and Herzegovina and Aid flow from UN agencies (US$) of Colombia?
Ensure brevity in your answer.  6.00e+04. What is the ratio of the Aid flow from UN agencies (US$) of Upper middle income in 1994 to that in 1995?
Provide a succinct answer. 0.89. What is the ratio of the Aid flow from UN agencies (US$) of Bosnia and Herzegovina in 1994 to that in 1995?
Your answer should be very brief. 0.45. What is the ratio of the Aid flow from UN agencies (US$) in Bulgaria in 1994 to that in 1995?
Provide a short and direct response. 1.8. What is the ratio of the Aid flow from UN agencies (US$) in Upper middle income in 1994 to that in 1996?
Keep it short and to the point. 0.79. What is the ratio of the Aid flow from UN agencies (US$) of Bosnia and Herzegovina in 1994 to that in 1996?
Offer a terse response. 0.03. What is the ratio of the Aid flow from UN agencies (US$) in Colombia in 1994 to that in 1996?
Make the answer very short. 5.01. What is the ratio of the Aid flow from UN agencies (US$) of Upper middle income in 1994 to that in 1997?
Keep it short and to the point. 0.65. What is the ratio of the Aid flow from UN agencies (US$) in Bosnia and Herzegovina in 1994 to that in 1997?
Give a very brief answer. 0.02. What is the ratio of the Aid flow from UN agencies (US$) of Bulgaria in 1994 to that in 1997?
Provide a succinct answer. 0.78. What is the ratio of the Aid flow from UN agencies (US$) of Colombia in 1994 to that in 1997?
Your answer should be compact. 3.76. What is the ratio of the Aid flow from UN agencies (US$) of Upper middle income in 1994 to that in 1998?
Your answer should be very brief. 0.69. What is the ratio of the Aid flow from UN agencies (US$) of Bosnia and Herzegovina in 1994 to that in 1998?
Offer a very short reply. 0.02. What is the ratio of the Aid flow from UN agencies (US$) in Bulgaria in 1994 to that in 1998?
Offer a very short reply. 0.51. What is the ratio of the Aid flow from UN agencies (US$) of Colombia in 1994 to that in 1998?
Provide a succinct answer. 2.24. What is the ratio of the Aid flow from UN agencies (US$) of Upper middle income in 1994 to that in 1999?
Offer a terse response. 1.5. What is the ratio of the Aid flow from UN agencies (US$) in Bosnia and Herzegovina in 1994 to that in 1999?
Keep it short and to the point. 0.02. What is the ratio of the Aid flow from UN agencies (US$) of Bulgaria in 1994 to that in 1999?
Make the answer very short. 0.76. What is the ratio of the Aid flow from UN agencies (US$) in Colombia in 1994 to that in 1999?
Provide a succinct answer. 5.37. What is the ratio of the Aid flow from UN agencies (US$) of Upper middle income in 1994 to that in 2000?
Offer a terse response. 1.44. What is the ratio of the Aid flow from UN agencies (US$) of Bulgaria in 1994 to that in 2000?
Offer a very short reply. 0.87. What is the ratio of the Aid flow from UN agencies (US$) in Upper middle income in 1994 to that in 2001?
Your answer should be compact. 1.74. What is the ratio of the Aid flow from UN agencies (US$) in Bosnia and Herzegovina in 1994 to that in 2001?
Give a very brief answer. 0.43. What is the ratio of the Aid flow from UN agencies (US$) of Bulgaria in 1994 to that in 2001?
Offer a very short reply. 1.11. What is the ratio of the Aid flow from UN agencies (US$) of Colombia in 1994 to that in 2001?
Your answer should be compact. 35.07. What is the ratio of the Aid flow from UN agencies (US$) of Upper middle income in 1995 to that in 1996?
Offer a terse response. 0.89. What is the ratio of the Aid flow from UN agencies (US$) in Bosnia and Herzegovina in 1995 to that in 1996?
Offer a very short reply. 0.06. What is the ratio of the Aid flow from UN agencies (US$) of Bulgaria in 1995 to that in 1996?
Give a very brief answer. 0.67. What is the ratio of the Aid flow from UN agencies (US$) of Upper middle income in 1995 to that in 1997?
Keep it short and to the point. 0.73. What is the ratio of the Aid flow from UN agencies (US$) of Bosnia and Herzegovina in 1995 to that in 1997?
Give a very brief answer. 0.04. What is the ratio of the Aid flow from UN agencies (US$) of Bulgaria in 1995 to that in 1997?
Offer a very short reply. 0.43. What is the ratio of the Aid flow from UN agencies (US$) in Upper middle income in 1995 to that in 1998?
Keep it short and to the point. 0.77. What is the ratio of the Aid flow from UN agencies (US$) in Bulgaria in 1995 to that in 1998?
Your response must be concise. 0.28. What is the ratio of the Aid flow from UN agencies (US$) in Upper middle income in 1995 to that in 1999?
Keep it short and to the point. 1.68. What is the ratio of the Aid flow from UN agencies (US$) of Bosnia and Herzegovina in 1995 to that in 1999?
Keep it short and to the point. 0.04. What is the ratio of the Aid flow from UN agencies (US$) in Bulgaria in 1995 to that in 1999?
Make the answer very short. 0.42. What is the ratio of the Aid flow from UN agencies (US$) in Upper middle income in 1995 to that in 2000?
Your answer should be very brief. 1.61. What is the ratio of the Aid flow from UN agencies (US$) in Bulgaria in 1995 to that in 2000?
Keep it short and to the point. 0.48. What is the ratio of the Aid flow from UN agencies (US$) in Upper middle income in 1995 to that in 2001?
Your answer should be compact. 1.95. What is the ratio of the Aid flow from UN agencies (US$) of Bosnia and Herzegovina in 1995 to that in 2001?
Keep it short and to the point. 0.95. What is the ratio of the Aid flow from UN agencies (US$) of Bulgaria in 1995 to that in 2001?
Make the answer very short. 0.62. What is the ratio of the Aid flow from UN agencies (US$) in Upper middle income in 1996 to that in 1997?
Ensure brevity in your answer.  0.82. What is the ratio of the Aid flow from UN agencies (US$) in Bosnia and Herzegovina in 1996 to that in 1997?
Your answer should be compact. 0.75. What is the ratio of the Aid flow from UN agencies (US$) in Bulgaria in 1996 to that in 1997?
Offer a very short reply. 0.65. What is the ratio of the Aid flow from UN agencies (US$) in Upper middle income in 1996 to that in 1998?
Your answer should be very brief. 0.86. What is the ratio of the Aid flow from UN agencies (US$) of Bosnia and Herzegovina in 1996 to that in 1998?
Provide a short and direct response. 0.71. What is the ratio of the Aid flow from UN agencies (US$) in Bulgaria in 1996 to that in 1998?
Your answer should be very brief. 0.43. What is the ratio of the Aid flow from UN agencies (US$) in Colombia in 1996 to that in 1998?
Keep it short and to the point. 0.45. What is the ratio of the Aid flow from UN agencies (US$) in Upper middle income in 1996 to that in 1999?
Offer a very short reply. 1.89. What is the ratio of the Aid flow from UN agencies (US$) of Bosnia and Herzegovina in 1996 to that in 1999?
Keep it short and to the point. 0.68. What is the ratio of the Aid flow from UN agencies (US$) in Bulgaria in 1996 to that in 1999?
Your answer should be very brief. 0.63. What is the ratio of the Aid flow from UN agencies (US$) in Colombia in 1996 to that in 1999?
Provide a short and direct response. 1.07. What is the ratio of the Aid flow from UN agencies (US$) in Upper middle income in 1996 to that in 2000?
Offer a very short reply. 1.81. What is the ratio of the Aid flow from UN agencies (US$) in Bulgaria in 1996 to that in 2000?
Offer a very short reply. 0.72. What is the ratio of the Aid flow from UN agencies (US$) of Upper middle income in 1996 to that in 2001?
Provide a succinct answer. 2.19. What is the ratio of the Aid flow from UN agencies (US$) of Bosnia and Herzegovina in 1996 to that in 2001?
Provide a short and direct response. 17. What is the ratio of the Aid flow from UN agencies (US$) in Colombia in 1996 to that in 2001?
Offer a terse response. 7. What is the ratio of the Aid flow from UN agencies (US$) of Upper middle income in 1997 to that in 1998?
Keep it short and to the point. 1.05. What is the ratio of the Aid flow from UN agencies (US$) in Bulgaria in 1997 to that in 1998?
Keep it short and to the point. 0.65. What is the ratio of the Aid flow from UN agencies (US$) of Colombia in 1997 to that in 1998?
Offer a terse response. 0.6. What is the ratio of the Aid flow from UN agencies (US$) in Upper middle income in 1997 to that in 1999?
Your answer should be compact. 2.3. What is the ratio of the Aid flow from UN agencies (US$) in Bosnia and Herzegovina in 1997 to that in 1999?
Provide a succinct answer. 0.9. What is the ratio of the Aid flow from UN agencies (US$) in Bulgaria in 1997 to that in 1999?
Your response must be concise. 0.97. What is the ratio of the Aid flow from UN agencies (US$) in Colombia in 1997 to that in 1999?
Offer a terse response. 1.43. What is the ratio of the Aid flow from UN agencies (US$) of Upper middle income in 1997 to that in 2000?
Make the answer very short. 2.2. What is the ratio of the Aid flow from UN agencies (US$) in Bulgaria in 1997 to that in 2000?
Keep it short and to the point. 1.11. What is the ratio of the Aid flow from UN agencies (US$) in Upper middle income in 1997 to that in 2001?
Keep it short and to the point. 2.66. What is the ratio of the Aid flow from UN agencies (US$) in Bosnia and Herzegovina in 1997 to that in 2001?
Ensure brevity in your answer.  22.62. What is the ratio of the Aid flow from UN agencies (US$) of Bulgaria in 1997 to that in 2001?
Make the answer very short. 1.42. What is the ratio of the Aid flow from UN agencies (US$) of Colombia in 1997 to that in 2001?
Your answer should be compact. 9.33. What is the ratio of the Aid flow from UN agencies (US$) in Upper middle income in 1998 to that in 1999?
Provide a short and direct response. 2.19. What is the ratio of the Aid flow from UN agencies (US$) of Bosnia and Herzegovina in 1998 to that in 1999?
Your answer should be compact. 0.95. What is the ratio of the Aid flow from UN agencies (US$) in Bulgaria in 1998 to that in 1999?
Offer a very short reply. 1.48. What is the ratio of the Aid flow from UN agencies (US$) of Colombia in 1998 to that in 1999?
Provide a short and direct response. 2.4. What is the ratio of the Aid flow from UN agencies (US$) of Upper middle income in 1998 to that in 2000?
Offer a very short reply. 2.1. What is the ratio of the Aid flow from UN agencies (US$) in Bulgaria in 1998 to that in 2000?
Keep it short and to the point. 1.7. What is the ratio of the Aid flow from UN agencies (US$) in Upper middle income in 1998 to that in 2001?
Give a very brief answer. 2.54. What is the ratio of the Aid flow from UN agencies (US$) of Bosnia and Herzegovina in 1998 to that in 2001?
Offer a very short reply. 23.81. What is the ratio of the Aid flow from UN agencies (US$) in Bulgaria in 1998 to that in 2001?
Give a very brief answer. 2.17. What is the ratio of the Aid flow from UN agencies (US$) in Colombia in 1998 to that in 2001?
Offer a very short reply. 15.67. What is the ratio of the Aid flow from UN agencies (US$) in Upper middle income in 1999 to that in 2000?
Keep it short and to the point. 0.96. What is the ratio of the Aid flow from UN agencies (US$) in Bulgaria in 1999 to that in 2000?
Provide a succinct answer. 1.14. What is the ratio of the Aid flow from UN agencies (US$) of Upper middle income in 1999 to that in 2001?
Provide a succinct answer. 1.16. What is the ratio of the Aid flow from UN agencies (US$) in Bosnia and Herzegovina in 1999 to that in 2001?
Give a very brief answer. 25.05. What is the ratio of the Aid flow from UN agencies (US$) of Bulgaria in 1999 to that in 2001?
Provide a short and direct response. 1.46. What is the ratio of the Aid flow from UN agencies (US$) of Colombia in 1999 to that in 2001?
Give a very brief answer. 6.53. What is the ratio of the Aid flow from UN agencies (US$) in Upper middle income in 2000 to that in 2001?
Offer a terse response. 1.21. What is the ratio of the Aid flow from UN agencies (US$) in Bulgaria in 2000 to that in 2001?
Your response must be concise. 1.28. What is the difference between the highest and the second highest Aid flow from UN agencies (US$) of Upper middle income?
Your answer should be very brief. 4.07e+06. What is the difference between the highest and the second highest Aid flow from UN agencies (US$) in Bosnia and Herzegovina?
Ensure brevity in your answer.  2.60e+05. What is the difference between the highest and the second highest Aid flow from UN agencies (US$) in Colombia?
Your answer should be very brief. 2.91e+06. What is the difference between the highest and the lowest Aid flow from UN agencies (US$) of Upper middle income?
Give a very brief answer. 5.42e+07. What is the difference between the highest and the lowest Aid flow from UN agencies (US$) in Bosnia and Herzegovina?
Offer a terse response. 5.26e+06. What is the difference between the highest and the lowest Aid flow from UN agencies (US$) of Bulgaria?
Offer a terse response. 1.01e+06. What is the difference between the highest and the lowest Aid flow from UN agencies (US$) of Colombia?
Ensure brevity in your answer.  5.26e+06. 